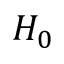<formula> <loc_0><loc_0><loc_500><loc_500>H _ { 0 }</formula> 